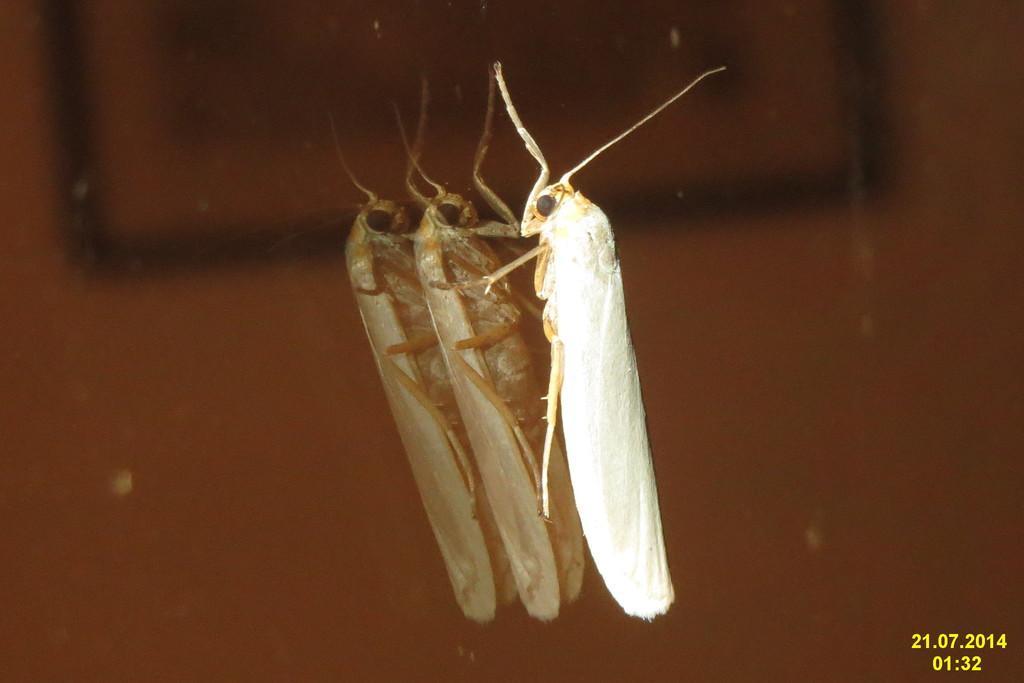How would you summarize this image in a sentence or two? In this image we can see a grasshopper on the mirror. 